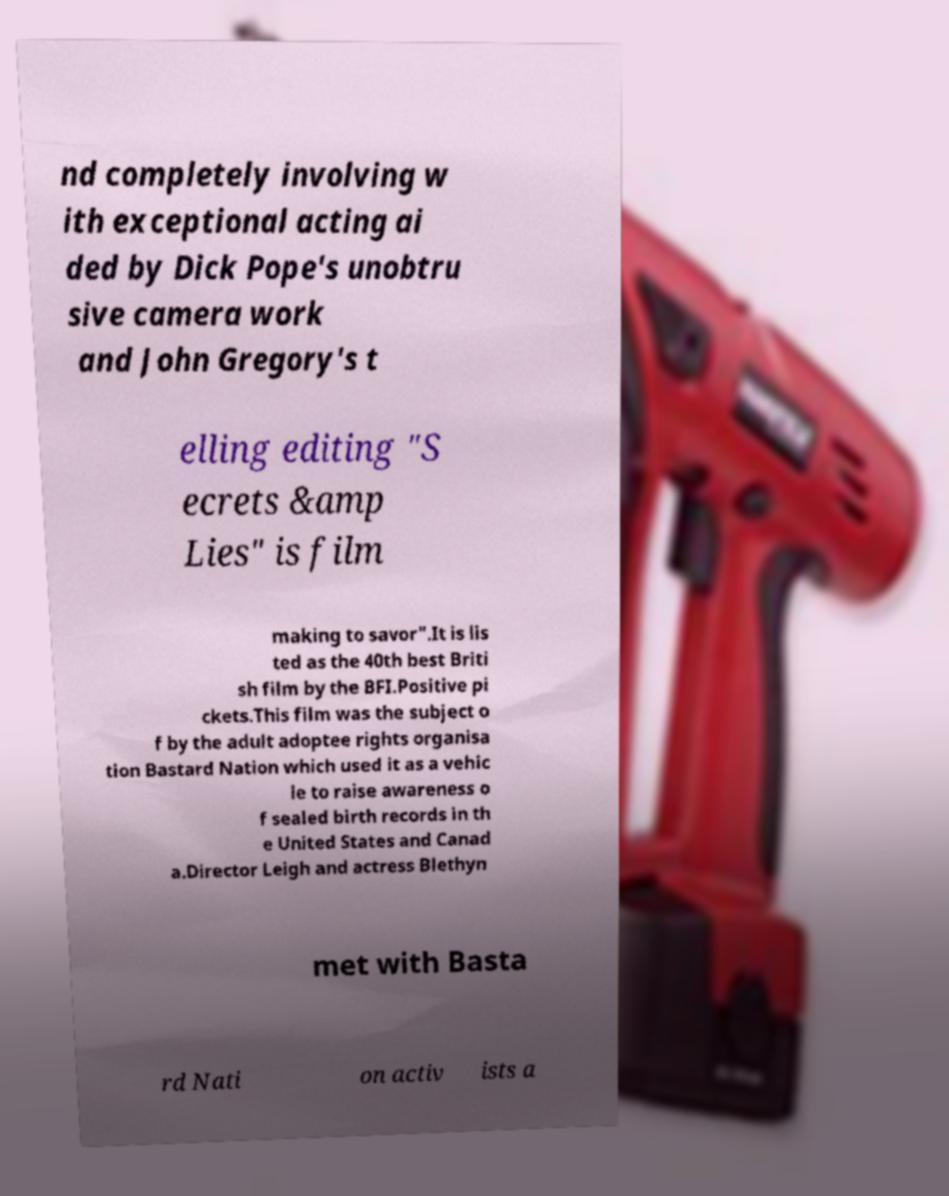Could you assist in decoding the text presented in this image and type it out clearly? nd completely involving w ith exceptional acting ai ded by Dick Pope's unobtru sive camera work and John Gregory's t elling editing "S ecrets &amp Lies" is film making to savor".It is lis ted as the 40th best Briti sh film by the BFI.Positive pi ckets.This film was the subject o f by the adult adoptee rights organisa tion Bastard Nation which used it as a vehic le to raise awareness o f sealed birth records in th e United States and Canad a.Director Leigh and actress Blethyn met with Basta rd Nati on activ ists a 